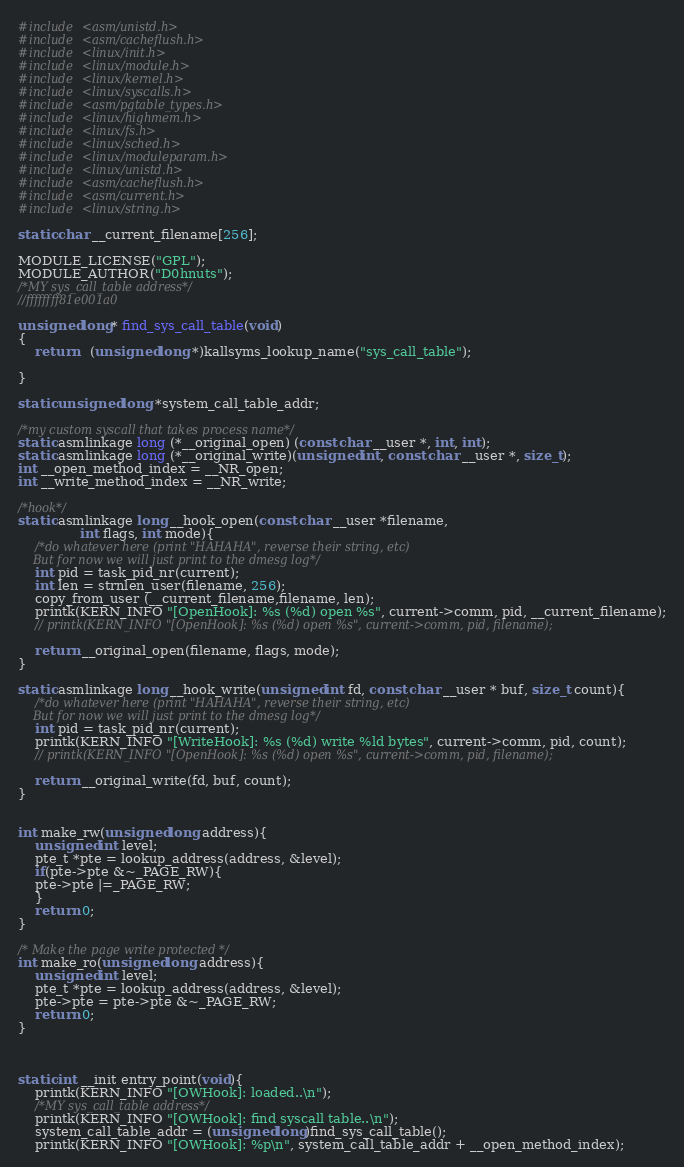Convert code to text. <code><loc_0><loc_0><loc_500><loc_500><_C_>#include <asm/unistd.h>
#include <asm/cacheflush.h>
#include <linux/init.h>
#include <linux/module.h>
#include <linux/kernel.h>
#include <linux/syscalls.h>
#include <asm/pgtable_types.h>
#include <linux/highmem.h>
#include <linux/fs.h>
#include <linux/sched.h>
#include <linux/moduleparam.h>
#include <linux/unistd.h>
#include <asm/cacheflush.h>
#include <asm/current.h>
#include <linux/string.h>

static char __current_filename[256];

MODULE_LICENSE("GPL");
MODULE_AUTHOR("D0hnuts");
/*MY sys_call_table address*/
//ffffffff81e001a0

unsigned long* find_sys_call_table(void)  
{
    return   (unsigned long *)kallsyms_lookup_name("sys_call_table");

}

static unsigned long *system_call_table_addr; 

/*my custom syscall that takes process name*/
static asmlinkage long (*__original_open) (const char __user *, int, int);
static asmlinkage long (*__original_write)(unsigned int, const char __user *, size_t);
int __open_method_index = __NR_open;
int __write_method_index = __NR_write;

/*hook*/
static asmlinkage long __hook_open(const char __user *filename,                       
               int flags, int mode){
    /*do whatever here (print "HAHAHA", reverse their string, etc)
    But for now we will just print to the dmesg log*/
    int pid = task_pid_nr(current);
    int len = strnlen_user(filename, 256);
    copy_from_user (__current_filename,filename, len);
    printk(KERN_INFO "[OpenHook]: %s (%d) open %s", current->comm, pid, __current_filename);
    // printk(KERN_INFO "[OpenHook]: %s (%d) open %s", current->comm, pid, filename);

    return __original_open(filename, flags, mode);
}

static asmlinkage long __hook_write(unsigned int fd, const char __user * buf, size_t count){
    /*do whatever here (print "HAHAHA", reverse their string, etc)
    But for now we will just print to the dmesg log*/
    int pid = task_pid_nr(current);
    printk(KERN_INFO "[WriteHook]: %s (%d) write %ld bytes", current->comm, pid, count);
    // printk(KERN_INFO "[OpenHook]: %s (%d) open %s", current->comm, pid, filename);

    return __original_write(fd, buf, count);
}


int make_rw(unsigned long address){
    unsigned int level;
    pte_t *pte = lookup_address(address, &level);
    if(pte->pte &~_PAGE_RW){
    pte->pte |=_PAGE_RW;
    }
    return 0;
}

/* Make the page write protected */
int make_ro(unsigned long address){
    unsigned int level;
    pte_t *pte = lookup_address(address, &level);
    pte->pte = pte->pte &~_PAGE_RW;
    return 0;
}



static int __init entry_point(void){
    printk(KERN_INFO "[OWHook]: loaded..\n");
    /*MY sys_call_table address*/
    printk(KERN_INFO "[OWHook]: find syscall table..\n");
    system_call_table_addr = (unsigned long)find_sys_call_table();
    printk(KERN_INFO "[OWHook]: %p\n", system_call_table_addr + __open_method_index);
</code> 